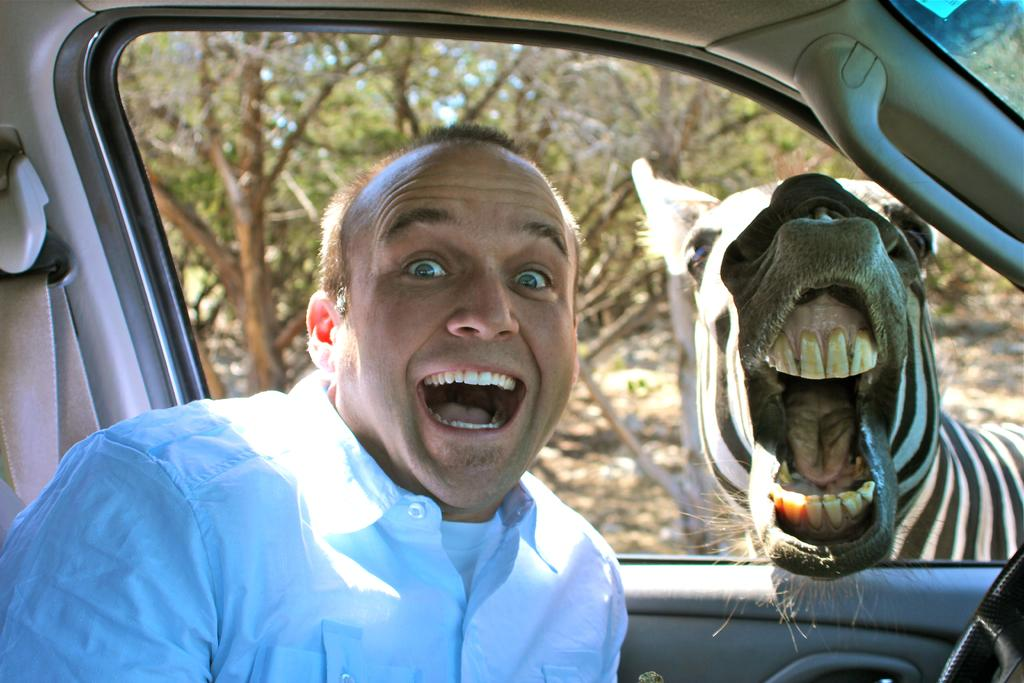What is the man in the image doing? The man is sitting inside a car in the image. How is the man feeling in the image? The man is smiling in the image. What animal is present in the image? There is a zebra in the image. What is the zebra doing in the image? The zebra has its mouth open in the image. What can be seen in the background of the image? There are trees in the background of the image. Where is the cannon located in the image? There is no cannon present in the image. What type of food is being served in the lunchroom in the image? There is no lunchroom present in the image. 